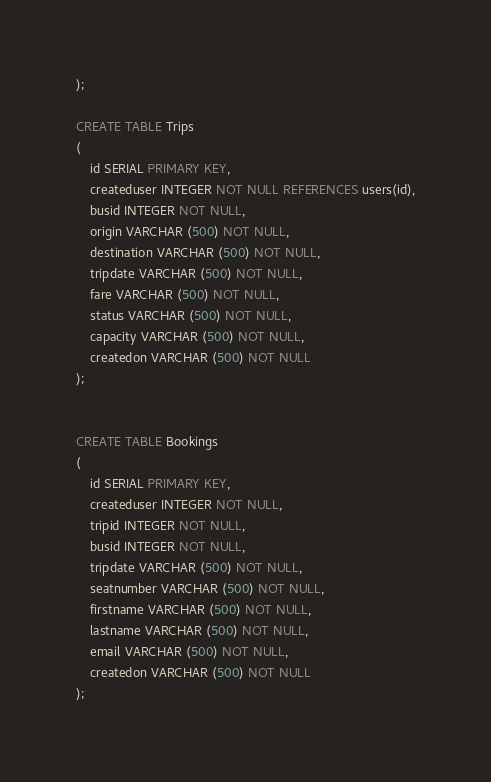<code> <loc_0><loc_0><loc_500><loc_500><_SQL_>);

CREATE TABLE Trips
(
    id SERIAL PRIMARY KEY,
    createduser INTEGER NOT NULL REFERENCES users(id),
    busid INTEGER NOT NULL,
    origin VARCHAR (500) NOT NULL,
    destination VARCHAR (500) NOT NULL,
    tripdate VARCHAR (500) NOT NULL,
    fare VARCHAR (500) NOT NULL,
    status VARCHAR (500) NOT NULL,
    capacity VARCHAR (500) NOT NULL,
    createdon VARCHAR (500) NOT NULL
);


CREATE TABLE Bookings
(
    id SERIAL PRIMARY KEY,
    createduser INTEGER NOT NULL,
    tripid INTEGER NOT NULL,
    busid INTEGER NOT NULL,
    tripdate VARCHAR (500) NOT NULL,
    seatnumber VARCHAR (500) NOT NULL,
    firstname VARCHAR (500) NOT NULL,
    lastname VARCHAR (500) NOT NULL,
    email VARCHAR (500) NOT NULL,
    createdon VARCHAR (500) NOT NULL
);</code> 